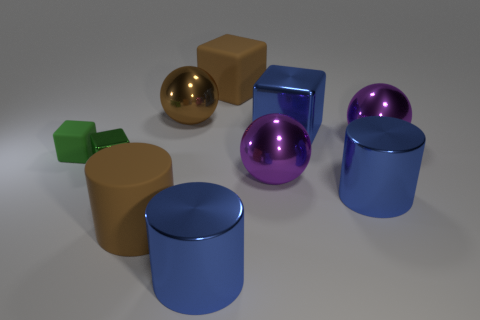Are there fewer big blue cylinders that are behind the tiny green shiny cube than shiny things that are left of the brown cube?
Your response must be concise. Yes. What is the material of the big cube that is the same color as the rubber cylinder?
Ensure brevity in your answer.  Rubber. What number of objects are cubes behind the brown metal object or big brown shiny balls?
Keep it short and to the point. 2. There is a purple metal object that is behind the green matte cube; is it the same size as the brown block?
Your answer should be compact. Yes. Are there fewer tiny matte objects left of the small green shiny cube than small green cubes?
Your answer should be very brief. Yes. What material is the other thing that is the same size as the green rubber thing?
Make the answer very short. Metal. How many tiny objects are brown balls or brown rubber cubes?
Make the answer very short. 0. How many things are big blue metal objects that are right of the blue block or blue metallic objects that are in front of the small shiny thing?
Offer a very short reply. 2. Are there fewer large blue shiny blocks than large purple cylinders?
Offer a terse response. No. There is a brown shiny object that is the same size as the blue cube; what shape is it?
Ensure brevity in your answer.  Sphere. 